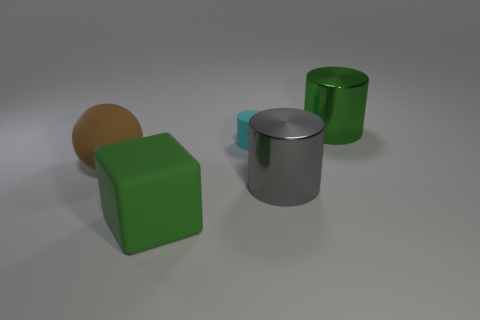Add 3 metallic things. How many objects exist? 8 Subtract all cylinders. How many objects are left? 2 Add 1 big metallic cylinders. How many big metallic cylinders exist? 3 Subtract 0 cyan blocks. How many objects are left? 5 Subtract all big gray things. Subtract all green shiny things. How many objects are left? 3 Add 3 big brown spheres. How many big brown spheres are left? 4 